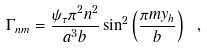<formula> <loc_0><loc_0><loc_500><loc_500>\Gamma _ { n m } = \frac { \psi _ { \tau } \pi ^ { 2 } n ^ { 2 } } { a ^ { 3 } b } \sin ^ { 2 } \left ( \frac { \pi m y _ { h } } { b } \right ) \ ,</formula> 